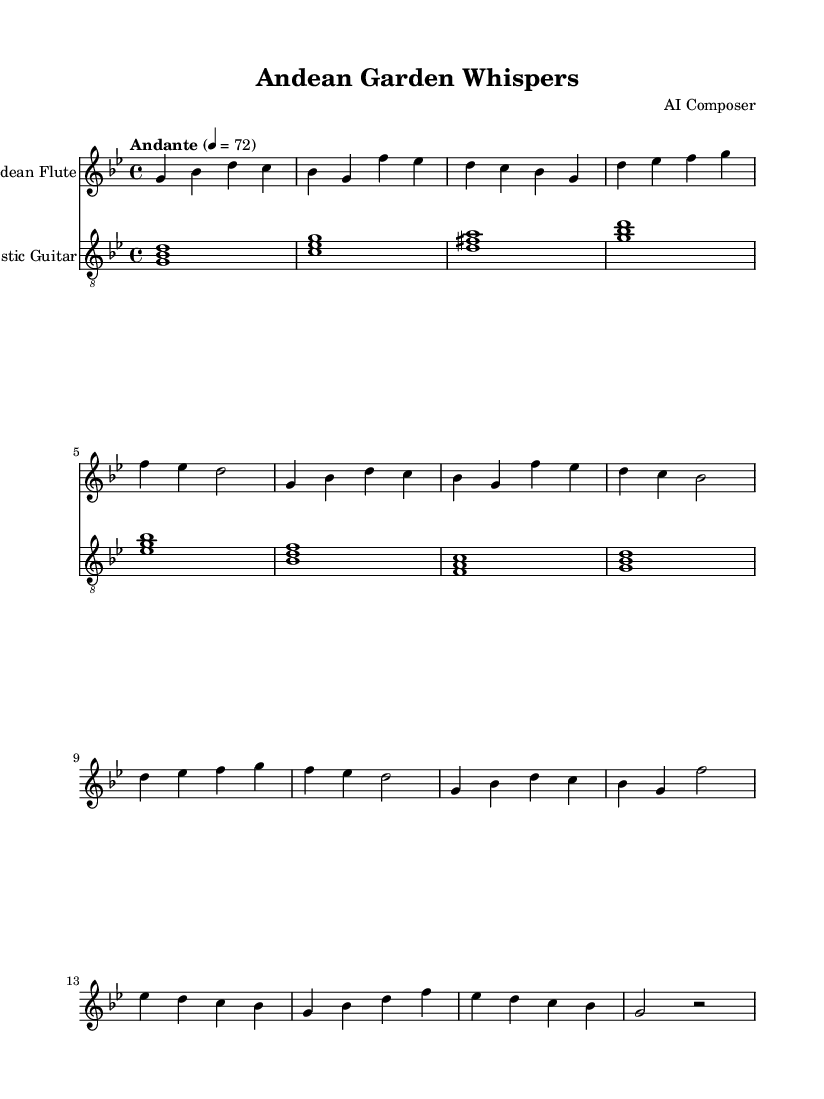What is the key signature of this music? The key signature is G minor, which has two flats (B flat and E flat) indicated in the sheet music.
Answer: G minor What is the time signature used in this piece? The time signature is 4/4, which means there are four beats per measure and a quarter note receives one beat. This is indicated at the beginning of the score.
Answer: 4/4 What is the tempo marking for this piece? The tempo marking is "Andante," which indicates a moderate walking pace, and is set to a metronome mark of 72 beats per minute.
Answer: Andante How many sections are there in the music? The piece comprises four distinct sections: Introduction, Verse, Chorus, and Bridge. These are organized sequentially and are typically marked in the sheet music.
Answer: Four What is the instrument used for the melody? The melody is played on the Andean Flute, as indicated by the instrument name on the staff specifically designated for it.
Answer: Andean Flute Which musical forms are represented in the structure of this music? The music exhibits a combination of strophic and verse-chorus form, as indicated by the repeated structure of verses and the clear distinction of chorus sections.
Answer: Strophic and verse-chorus form 